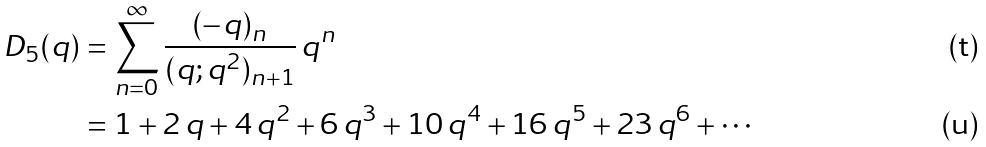Convert formula to latex. <formula><loc_0><loc_0><loc_500><loc_500>D _ { 5 } ( q ) & = \sum _ { n = 0 } ^ { \infty } \frac { ( - q ) _ { n } } { ( q ; q ^ { 2 } ) _ { n + 1 } } \, q ^ { n } \\ & = 1 + 2 \, q + 4 \, q ^ { 2 } + 6 \, q ^ { 3 } + 1 0 \, q ^ { 4 } + 1 6 \, q ^ { 5 } + 2 3 \, q ^ { 6 } + \cdots</formula> 